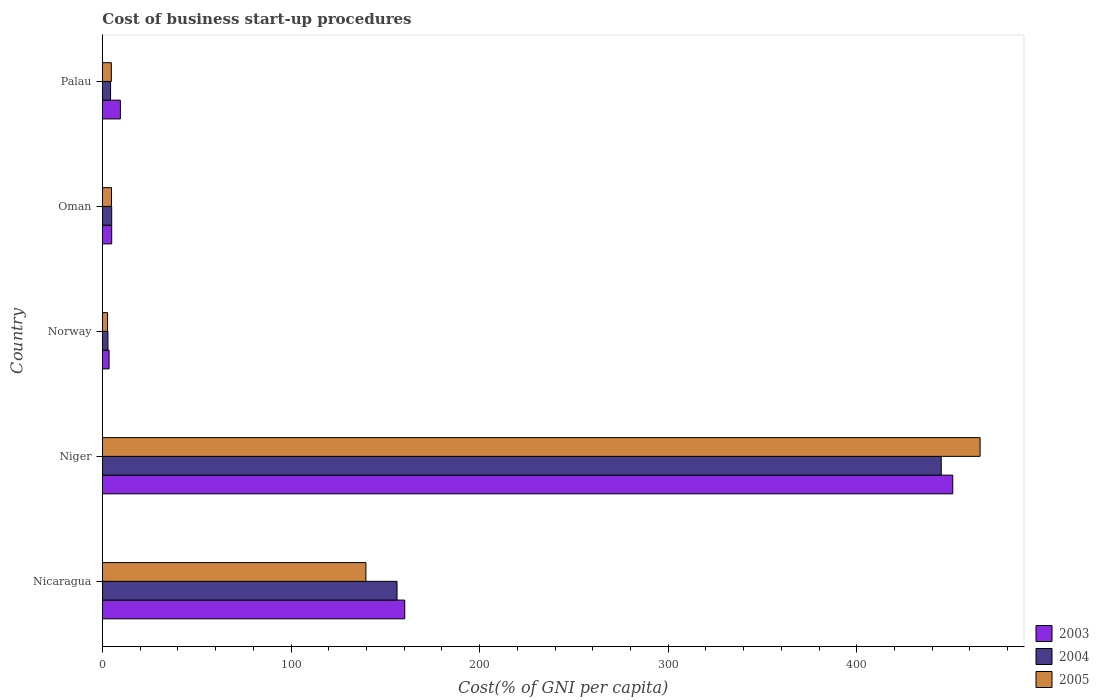How many bars are there on the 1st tick from the bottom?
Offer a very short reply. 3. What is the label of the 2nd group of bars from the top?
Offer a terse response. Oman. Across all countries, what is the maximum cost of business start-up procedures in 2003?
Provide a short and direct response. 450.9. Across all countries, what is the minimum cost of business start-up procedures in 2004?
Give a very brief answer. 2.9. In which country was the cost of business start-up procedures in 2004 maximum?
Offer a very short reply. Niger. What is the total cost of business start-up procedures in 2005 in the graph?
Provide a short and direct response. 617.3. What is the difference between the cost of business start-up procedures in 2005 in Niger and that in Palau?
Provide a short and direct response. 460.7. What is the difference between the cost of business start-up procedures in 2005 in Nicaragua and the cost of business start-up procedures in 2004 in Palau?
Keep it short and to the point. 135.4. What is the average cost of business start-up procedures in 2003 per country?
Your response must be concise. 125.82. What is the difference between the cost of business start-up procedures in 2005 and cost of business start-up procedures in 2003 in Norway?
Provide a succinct answer. -0.8. What is the ratio of the cost of business start-up procedures in 2003 in Niger to that in Oman?
Make the answer very short. 92.02. Is the cost of business start-up procedures in 2005 in Niger less than that in Palau?
Give a very brief answer. No. What is the difference between the highest and the second highest cost of business start-up procedures in 2005?
Offer a terse response. 325.7. What is the difference between the highest and the lowest cost of business start-up procedures in 2004?
Ensure brevity in your answer.  441.9. What does the 1st bar from the bottom in Niger represents?
Provide a short and direct response. 2003. How many bars are there?
Your answer should be compact. 15. What is the difference between two consecutive major ticks on the X-axis?
Provide a short and direct response. 100. Are the values on the major ticks of X-axis written in scientific E-notation?
Offer a very short reply. No. What is the title of the graph?
Your answer should be compact. Cost of business start-up procedures. Does "1979" appear as one of the legend labels in the graph?
Provide a succinct answer. No. What is the label or title of the X-axis?
Your answer should be compact. Cost(% of GNI per capita). What is the label or title of the Y-axis?
Your response must be concise. Country. What is the Cost(% of GNI per capita) in 2003 in Nicaragua?
Offer a terse response. 160.3. What is the Cost(% of GNI per capita) in 2004 in Nicaragua?
Provide a succinct answer. 156.2. What is the Cost(% of GNI per capita) in 2005 in Nicaragua?
Your answer should be very brief. 139.7. What is the Cost(% of GNI per capita) of 2003 in Niger?
Your response must be concise. 450.9. What is the Cost(% of GNI per capita) of 2004 in Niger?
Make the answer very short. 444.8. What is the Cost(% of GNI per capita) of 2005 in Niger?
Make the answer very short. 465.4. What is the Cost(% of GNI per capita) in 2003 in Palau?
Provide a short and direct response. 9.5. What is the Cost(% of GNI per capita) of 2005 in Palau?
Offer a terse response. 4.7. Across all countries, what is the maximum Cost(% of GNI per capita) of 2003?
Your answer should be compact. 450.9. Across all countries, what is the maximum Cost(% of GNI per capita) of 2004?
Your answer should be very brief. 444.8. Across all countries, what is the maximum Cost(% of GNI per capita) of 2005?
Ensure brevity in your answer.  465.4. What is the total Cost(% of GNI per capita) in 2003 in the graph?
Your answer should be very brief. 629.1. What is the total Cost(% of GNI per capita) of 2004 in the graph?
Offer a very short reply. 613.1. What is the total Cost(% of GNI per capita) of 2005 in the graph?
Keep it short and to the point. 617.3. What is the difference between the Cost(% of GNI per capita) in 2003 in Nicaragua and that in Niger?
Provide a succinct answer. -290.6. What is the difference between the Cost(% of GNI per capita) in 2004 in Nicaragua and that in Niger?
Provide a succinct answer. -288.6. What is the difference between the Cost(% of GNI per capita) in 2005 in Nicaragua and that in Niger?
Your response must be concise. -325.7. What is the difference between the Cost(% of GNI per capita) of 2003 in Nicaragua and that in Norway?
Provide a short and direct response. 156.8. What is the difference between the Cost(% of GNI per capita) in 2004 in Nicaragua and that in Norway?
Make the answer very short. 153.3. What is the difference between the Cost(% of GNI per capita) of 2005 in Nicaragua and that in Norway?
Keep it short and to the point. 137. What is the difference between the Cost(% of GNI per capita) in 2003 in Nicaragua and that in Oman?
Give a very brief answer. 155.4. What is the difference between the Cost(% of GNI per capita) of 2004 in Nicaragua and that in Oman?
Make the answer very short. 151.3. What is the difference between the Cost(% of GNI per capita) in 2005 in Nicaragua and that in Oman?
Your answer should be very brief. 134.9. What is the difference between the Cost(% of GNI per capita) of 2003 in Nicaragua and that in Palau?
Offer a very short reply. 150.8. What is the difference between the Cost(% of GNI per capita) of 2004 in Nicaragua and that in Palau?
Offer a terse response. 151.9. What is the difference between the Cost(% of GNI per capita) in 2005 in Nicaragua and that in Palau?
Make the answer very short. 135. What is the difference between the Cost(% of GNI per capita) of 2003 in Niger and that in Norway?
Your answer should be compact. 447.4. What is the difference between the Cost(% of GNI per capita) of 2004 in Niger and that in Norway?
Your response must be concise. 441.9. What is the difference between the Cost(% of GNI per capita) in 2005 in Niger and that in Norway?
Make the answer very short. 462.7. What is the difference between the Cost(% of GNI per capita) in 2003 in Niger and that in Oman?
Keep it short and to the point. 446. What is the difference between the Cost(% of GNI per capita) in 2004 in Niger and that in Oman?
Your answer should be compact. 439.9. What is the difference between the Cost(% of GNI per capita) in 2005 in Niger and that in Oman?
Ensure brevity in your answer.  460.6. What is the difference between the Cost(% of GNI per capita) of 2003 in Niger and that in Palau?
Provide a short and direct response. 441.4. What is the difference between the Cost(% of GNI per capita) of 2004 in Niger and that in Palau?
Your answer should be very brief. 440.5. What is the difference between the Cost(% of GNI per capita) in 2005 in Niger and that in Palau?
Ensure brevity in your answer.  460.7. What is the difference between the Cost(% of GNI per capita) of 2003 in Norway and that in Oman?
Offer a terse response. -1.4. What is the difference between the Cost(% of GNI per capita) in 2004 in Norway and that in Oman?
Provide a short and direct response. -2. What is the difference between the Cost(% of GNI per capita) of 2005 in Norway and that in Oman?
Give a very brief answer. -2.1. What is the difference between the Cost(% of GNI per capita) in 2003 in Norway and that in Palau?
Offer a very short reply. -6. What is the difference between the Cost(% of GNI per capita) in 2004 in Norway and that in Palau?
Your answer should be very brief. -1.4. What is the difference between the Cost(% of GNI per capita) in 2003 in Nicaragua and the Cost(% of GNI per capita) in 2004 in Niger?
Provide a succinct answer. -284.5. What is the difference between the Cost(% of GNI per capita) of 2003 in Nicaragua and the Cost(% of GNI per capita) of 2005 in Niger?
Offer a very short reply. -305.1. What is the difference between the Cost(% of GNI per capita) in 2004 in Nicaragua and the Cost(% of GNI per capita) in 2005 in Niger?
Your answer should be compact. -309.2. What is the difference between the Cost(% of GNI per capita) of 2003 in Nicaragua and the Cost(% of GNI per capita) of 2004 in Norway?
Keep it short and to the point. 157.4. What is the difference between the Cost(% of GNI per capita) of 2003 in Nicaragua and the Cost(% of GNI per capita) of 2005 in Norway?
Your answer should be very brief. 157.6. What is the difference between the Cost(% of GNI per capita) in 2004 in Nicaragua and the Cost(% of GNI per capita) in 2005 in Norway?
Your response must be concise. 153.5. What is the difference between the Cost(% of GNI per capita) of 2003 in Nicaragua and the Cost(% of GNI per capita) of 2004 in Oman?
Your response must be concise. 155.4. What is the difference between the Cost(% of GNI per capita) in 2003 in Nicaragua and the Cost(% of GNI per capita) in 2005 in Oman?
Your answer should be compact. 155.5. What is the difference between the Cost(% of GNI per capita) of 2004 in Nicaragua and the Cost(% of GNI per capita) of 2005 in Oman?
Provide a succinct answer. 151.4. What is the difference between the Cost(% of GNI per capita) of 2003 in Nicaragua and the Cost(% of GNI per capita) of 2004 in Palau?
Offer a very short reply. 156. What is the difference between the Cost(% of GNI per capita) in 2003 in Nicaragua and the Cost(% of GNI per capita) in 2005 in Palau?
Your response must be concise. 155.6. What is the difference between the Cost(% of GNI per capita) in 2004 in Nicaragua and the Cost(% of GNI per capita) in 2005 in Palau?
Offer a very short reply. 151.5. What is the difference between the Cost(% of GNI per capita) of 2003 in Niger and the Cost(% of GNI per capita) of 2004 in Norway?
Offer a terse response. 448. What is the difference between the Cost(% of GNI per capita) in 2003 in Niger and the Cost(% of GNI per capita) in 2005 in Norway?
Offer a very short reply. 448.2. What is the difference between the Cost(% of GNI per capita) in 2004 in Niger and the Cost(% of GNI per capita) in 2005 in Norway?
Your answer should be compact. 442.1. What is the difference between the Cost(% of GNI per capita) of 2003 in Niger and the Cost(% of GNI per capita) of 2004 in Oman?
Your answer should be very brief. 446. What is the difference between the Cost(% of GNI per capita) of 2003 in Niger and the Cost(% of GNI per capita) of 2005 in Oman?
Keep it short and to the point. 446.1. What is the difference between the Cost(% of GNI per capita) in 2004 in Niger and the Cost(% of GNI per capita) in 2005 in Oman?
Your response must be concise. 440. What is the difference between the Cost(% of GNI per capita) of 2003 in Niger and the Cost(% of GNI per capita) of 2004 in Palau?
Give a very brief answer. 446.6. What is the difference between the Cost(% of GNI per capita) in 2003 in Niger and the Cost(% of GNI per capita) in 2005 in Palau?
Ensure brevity in your answer.  446.2. What is the difference between the Cost(% of GNI per capita) in 2004 in Niger and the Cost(% of GNI per capita) in 2005 in Palau?
Provide a short and direct response. 440.1. What is the difference between the Cost(% of GNI per capita) of 2003 in Norway and the Cost(% of GNI per capita) of 2005 in Oman?
Make the answer very short. -1.3. What is the difference between the Cost(% of GNI per capita) in 2003 in Norway and the Cost(% of GNI per capita) in 2004 in Palau?
Provide a short and direct response. -0.8. What is the difference between the Cost(% of GNI per capita) in 2003 in Oman and the Cost(% of GNI per capita) in 2005 in Palau?
Make the answer very short. 0.2. What is the average Cost(% of GNI per capita) in 2003 per country?
Keep it short and to the point. 125.82. What is the average Cost(% of GNI per capita) of 2004 per country?
Your answer should be compact. 122.62. What is the average Cost(% of GNI per capita) in 2005 per country?
Your response must be concise. 123.46. What is the difference between the Cost(% of GNI per capita) of 2003 and Cost(% of GNI per capita) of 2004 in Nicaragua?
Provide a short and direct response. 4.1. What is the difference between the Cost(% of GNI per capita) of 2003 and Cost(% of GNI per capita) of 2005 in Nicaragua?
Make the answer very short. 20.6. What is the difference between the Cost(% of GNI per capita) of 2003 and Cost(% of GNI per capita) of 2004 in Niger?
Your response must be concise. 6.1. What is the difference between the Cost(% of GNI per capita) of 2003 and Cost(% of GNI per capita) of 2005 in Niger?
Make the answer very short. -14.5. What is the difference between the Cost(% of GNI per capita) of 2004 and Cost(% of GNI per capita) of 2005 in Niger?
Ensure brevity in your answer.  -20.6. What is the difference between the Cost(% of GNI per capita) in 2003 and Cost(% of GNI per capita) in 2004 in Norway?
Your answer should be compact. 0.6. What is the difference between the Cost(% of GNI per capita) of 2004 and Cost(% of GNI per capita) of 2005 in Norway?
Provide a short and direct response. 0.2. What is the difference between the Cost(% of GNI per capita) of 2003 and Cost(% of GNI per capita) of 2004 in Oman?
Your response must be concise. 0. What is the difference between the Cost(% of GNI per capita) of 2004 and Cost(% of GNI per capita) of 2005 in Oman?
Provide a short and direct response. 0.1. What is the difference between the Cost(% of GNI per capita) of 2003 and Cost(% of GNI per capita) of 2005 in Palau?
Provide a succinct answer. 4.8. What is the difference between the Cost(% of GNI per capita) in 2004 and Cost(% of GNI per capita) in 2005 in Palau?
Your response must be concise. -0.4. What is the ratio of the Cost(% of GNI per capita) of 2003 in Nicaragua to that in Niger?
Give a very brief answer. 0.36. What is the ratio of the Cost(% of GNI per capita) in 2004 in Nicaragua to that in Niger?
Ensure brevity in your answer.  0.35. What is the ratio of the Cost(% of GNI per capita) in 2005 in Nicaragua to that in Niger?
Ensure brevity in your answer.  0.3. What is the ratio of the Cost(% of GNI per capita) in 2003 in Nicaragua to that in Norway?
Make the answer very short. 45.8. What is the ratio of the Cost(% of GNI per capita) in 2004 in Nicaragua to that in Norway?
Give a very brief answer. 53.86. What is the ratio of the Cost(% of GNI per capita) in 2005 in Nicaragua to that in Norway?
Offer a terse response. 51.74. What is the ratio of the Cost(% of GNI per capita) in 2003 in Nicaragua to that in Oman?
Your answer should be compact. 32.71. What is the ratio of the Cost(% of GNI per capita) in 2004 in Nicaragua to that in Oman?
Make the answer very short. 31.88. What is the ratio of the Cost(% of GNI per capita) of 2005 in Nicaragua to that in Oman?
Your response must be concise. 29.1. What is the ratio of the Cost(% of GNI per capita) in 2003 in Nicaragua to that in Palau?
Give a very brief answer. 16.87. What is the ratio of the Cost(% of GNI per capita) of 2004 in Nicaragua to that in Palau?
Ensure brevity in your answer.  36.33. What is the ratio of the Cost(% of GNI per capita) in 2005 in Nicaragua to that in Palau?
Your answer should be compact. 29.72. What is the ratio of the Cost(% of GNI per capita) in 2003 in Niger to that in Norway?
Provide a succinct answer. 128.83. What is the ratio of the Cost(% of GNI per capita) of 2004 in Niger to that in Norway?
Offer a very short reply. 153.38. What is the ratio of the Cost(% of GNI per capita) of 2005 in Niger to that in Norway?
Keep it short and to the point. 172.37. What is the ratio of the Cost(% of GNI per capita) of 2003 in Niger to that in Oman?
Your answer should be compact. 92.02. What is the ratio of the Cost(% of GNI per capita) of 2004 in Niger to that in Oman?
Offer a terse response. 90.78. What is the ratio of the Cost(% of GNI per capita) of 2005 in Niger to that in Oman?
Offer a terse response. 96.96. What is the ratio of the Cost(% of GNI per capita) of 2003 in Niger to that in Palau?
Provide a short and direct response. 47.46. What is the ratio of the Cost(% of GNI per capita) of 2004 in Niger to that in Palau?
Provide a succinct answer. 103.44. What is the ratio of the Cost(% of GNI per capita) of 2005 in Niger to that in Palau?
Provide a short and direct response. 99.02. What is the ratio of the Cost(% of GNI per capita) in 2003 in Norway to that in Oman?
Give a very brief answer. 0.71. What is the ratio of the Cost(% of GNI per capita) of 2004 in Norway to that in Oman?
Offer a very short reply. 0.59. What is the ratio of the Cost(% of GNI per capita) in 2005 in Norway to that in Oman?
Your answer should be very brief. 0.56. What is the ratio of the Cost(% of GNI per capita) in 2003 in Norway to that in Palau?
Provide a succinct answer. 0.37. What is the ratio of the Cost(% of GNI per capita) in 2004 in Norway to that in Palau?
Provide a short and direct response. 0.67. What is the ratio of the Cost(% of GNI per capita) of 2005 in Norway to that in Palau?
Give a very brief answer. 0.57. What is the ratio of the Cost(% of GNI per capita) in 2003 in Oman to that in Palau?
Make the answer very short. 0.52. What is the ratio of the Cost(% of GNI per capita) of 2004 in Oman to that in Palau?
Provide a succinct answer. 1.14. What is the ratio of the Cost(% of GNI per capita) of 2005 in Oman to that in Palau?
Provide a short and direct response. 1.02. What is the difference between the highest and the second highest Cost(% of GNI per capita) of 2003?
Give a very brief answer. 290.6. What is the difference between the highest and the second highest Cost(% of GNI per capita) of 2004?
Offer a terse response. 288.6. What is the difference between the highest and the second highest Cost(% of GNI per capita) of 2005?
Make the answer very short. 325.7. What is the difference between the highest and the lowest Cost(% of GNI per capita) of 2003?
Offer a very short reply. 447.4. What is the difference between the highest and the lowest Cost(% of GNI per capita) of 2004?
Offer a very short reply. 441.9. What is the difference between the highest and the lowest Cost(% of GNI per capita) in 2005?
Your response must be concise. 462.7. 